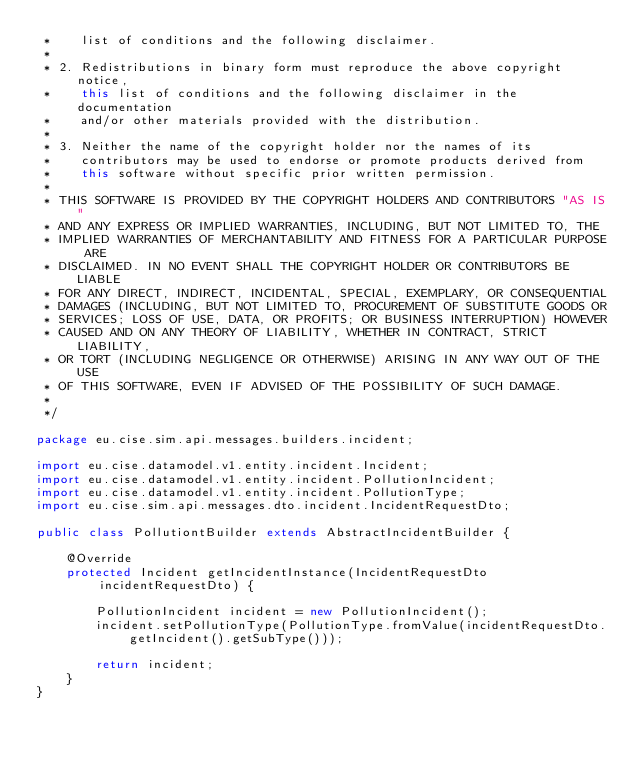<code> <loc_0><loc_0><loc_500><loc_500><_Java_> *    list of conditions and the following disclaimer.
 *
 * 2. Redistributions in binary form must reproduce the above copyright notice,
 *    this list of conditions and the following disclaimer in the documentation
 *    and/or other materials provided with the distribution.
 *
 * 3. Neither the name of the copyright holder nor the names of its
 *    contributors may be used to endorse or promote products derived from
 *    this software without specific prior written permission.
 *
 * THIS SOFTWARE IS PROVIDED BY THE COPYRIGHT HOLDERS AND CONTRIBUTORS "AS IS"
 * AND ANY EXPRESS OR IMPLIED WARRANTIES, INCLUDING, BUT NOT LIMITED TO, THE
 * IMPLIED WARRANTIES OF MERCHANTABILITY AND FITNESS FOR A PARTICULAR PURPOSE ARE
 * DISCLAIMED. IN NO EVENT SHALL THE COPYRIGHT HOLDER OR CONTRIBUTORS BE LIABLE
 * FOR ANY DIRECT, INDIRECT, INCIDENTAL, SPECIAL, EXEMPLARY, OR CONSEQUENTIAL
 * DAMAGES (INCLUDING, BUT NOT LIMITED TO, PROCUREMENT OF SUBSTITUTE GOODS OR
 * SERVICES; LOSS OF USE, DATA, OR PROFITS; OR BUSINESS INTERRUPTION) HOWEVER
 * CAUSED AND ON ANY THEORY OF LIABILITY, WHETHER IN CONTRACT, STRICT LIABILITY,
 * OR TORT (INCLUDING NEGLIGENCE OR OTHERWISE) ARISING IN ANY WAY OUT OF THE USE
 * OF THIS SOFTWARE, EVEN IF ADVISED OF THE POSSIBILITY OF SUCH DAMAGE.
 *
 */

package eu.cise.sim.api.messages.builders.incident;

import eu.cise.datamodel.v1.entity.incident.Incident;
import eu.cise.datamodel.v1.entity.incident.PollutionIncident;
import eu.cise.datamodel.v1.entity.incident.PollutionType;
import eu.cise.sim.api.messages.dto.incident.IncidentRequestDto;

public class PollutiontBuilder extends AbstractIncidentBuilder {

    @Override
    protected Incident getIncidentInstance(IncidentRequestDto incidentRequestDto) {

        PollutionIncident incident = new PollutionIncident();
        incident.setPollutionType(PollutionType.fromValue(incidentRequestDto.getIncident().getSubType()));

        return incident;
    }
}
</code> 